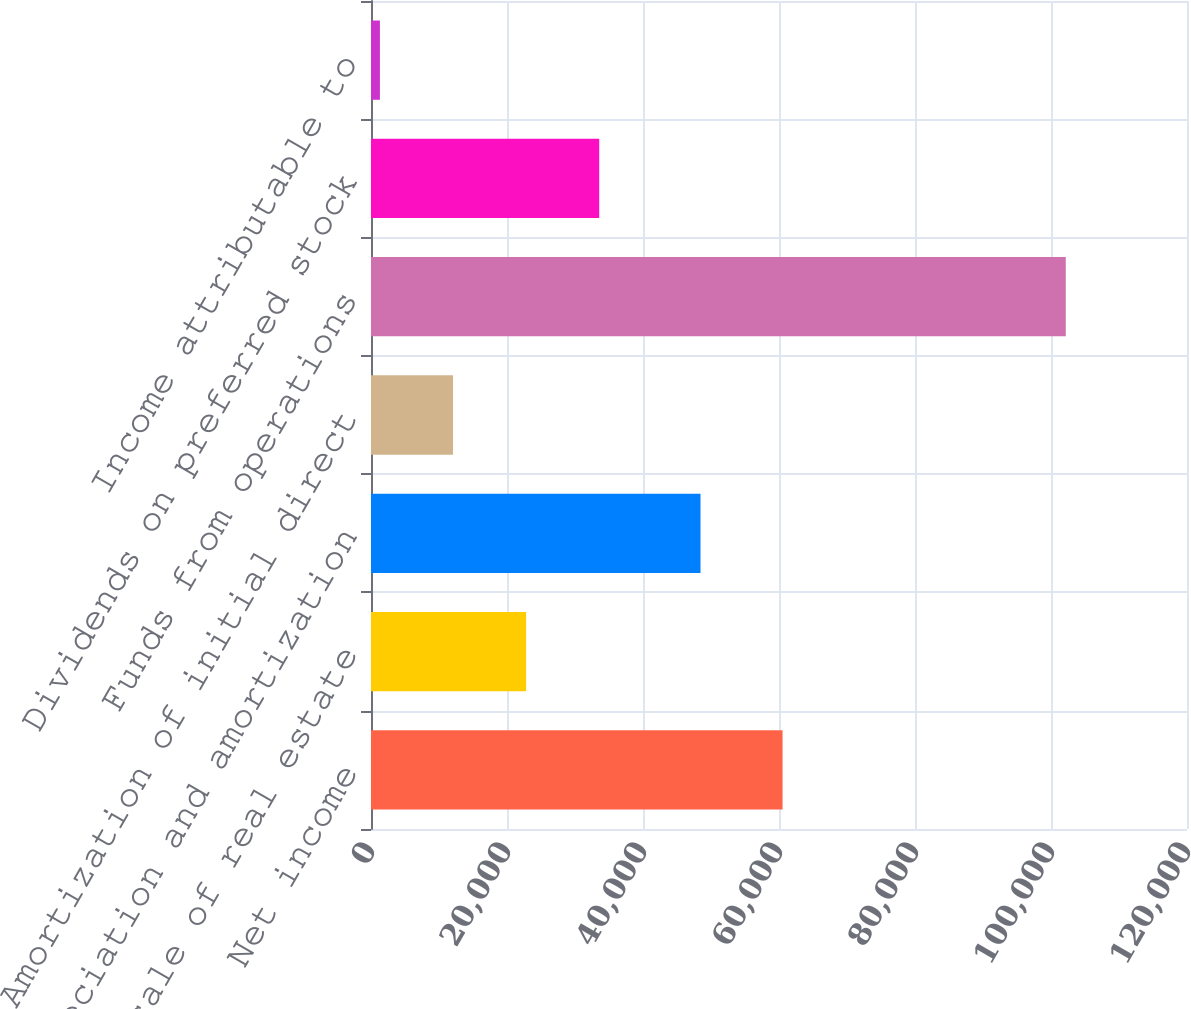Convert chart to OTSL. <chart><loc_0><loc_0><loc_500><loc_500><bar_chart><fcel>Net income<fcel>Gain on sale of real estate<fcel>Depreciation and amortization<fcel>Amortization of initial direct<fcel>Funds from operations<fcel>Dividends on preferred stock<fcel>Income attributable to<nl><fcel>60523<fcel>22811.2<fcel>48456<fcel>12061.1<fcel>102173<fcel>33561.3<fcel>1311<nl></chart> 